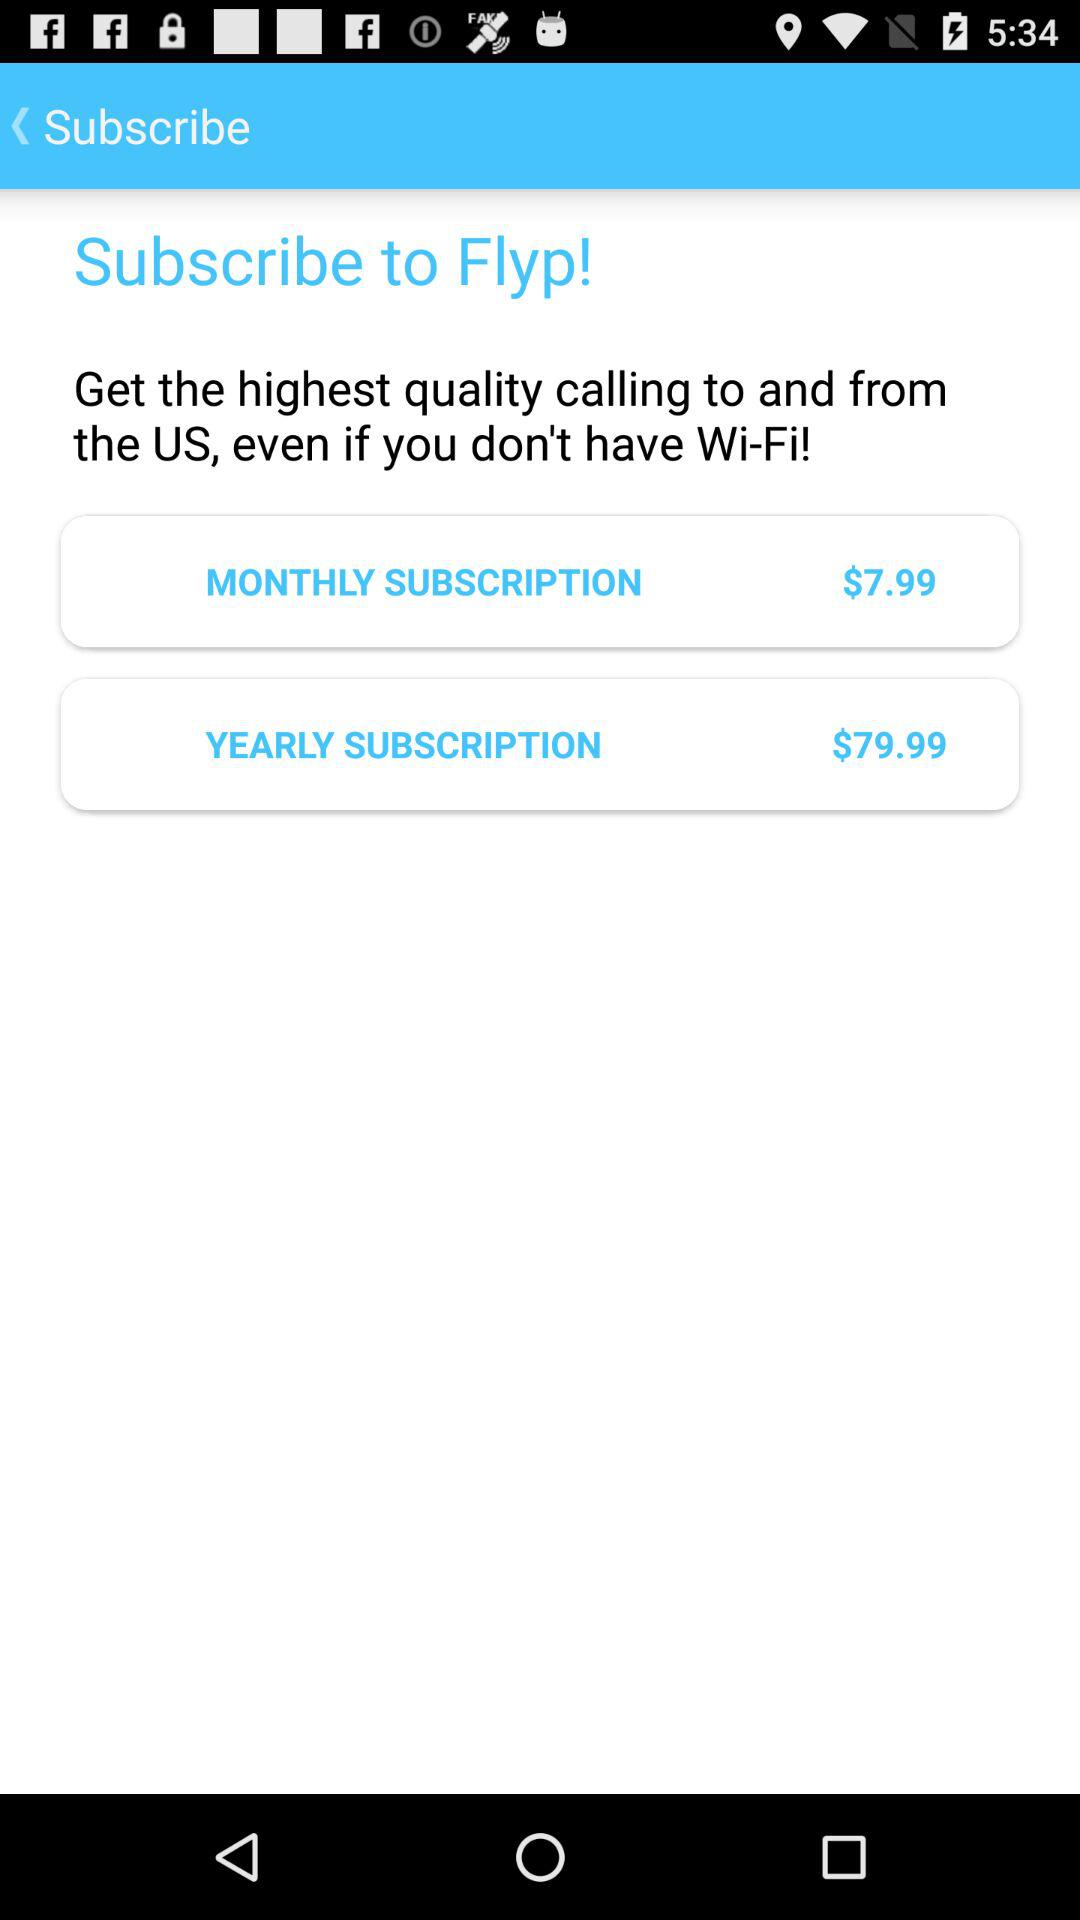How much more expensive is the yearly subscription than the monthly subscription?
Answer the question using a single word or phrase. $72 